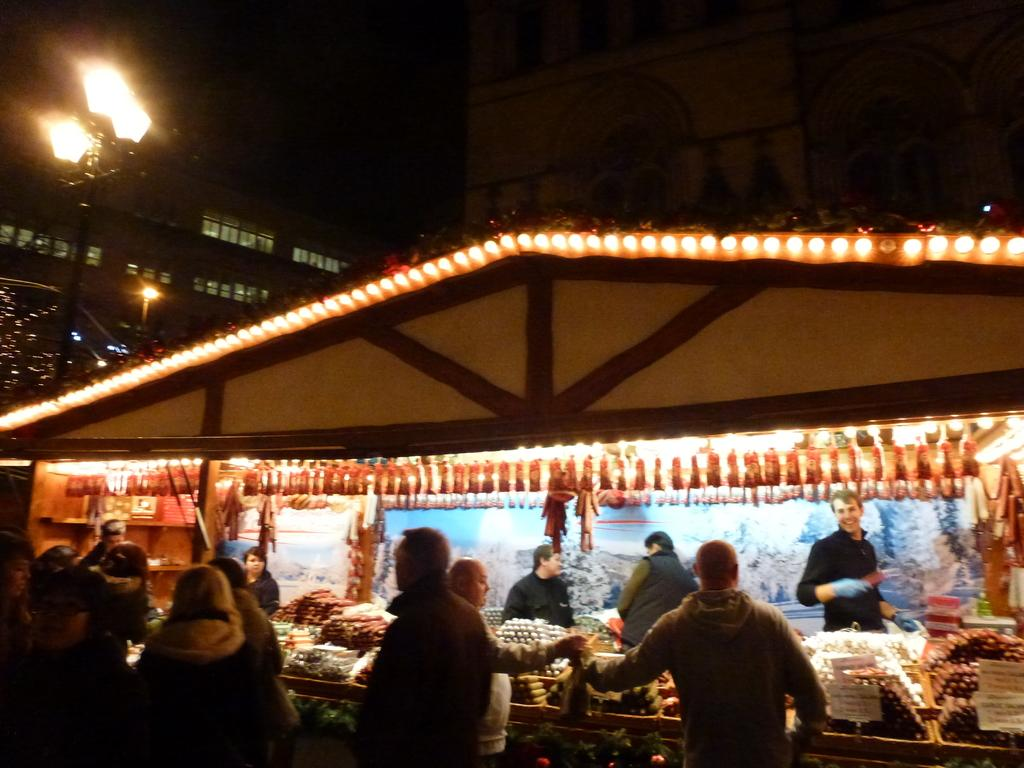What type of establishment is shown in the image? There is a store in the image. Can you describe the people in the image? There are people in the image. What objects can be seen in the image? There are boards and some other objects in the image. What architectural features are visible at the top of the image? There are buildings, walls, glass windows, and a pole at the top of the image. How is the view at the top of the image described? The view at the top of the image is dark. Are there any lights visible in the image? Yes, there are lights in the image. How does the store handle payment for the worms in the image? There are no worms present in the image, and the store does not handle payment for them. 